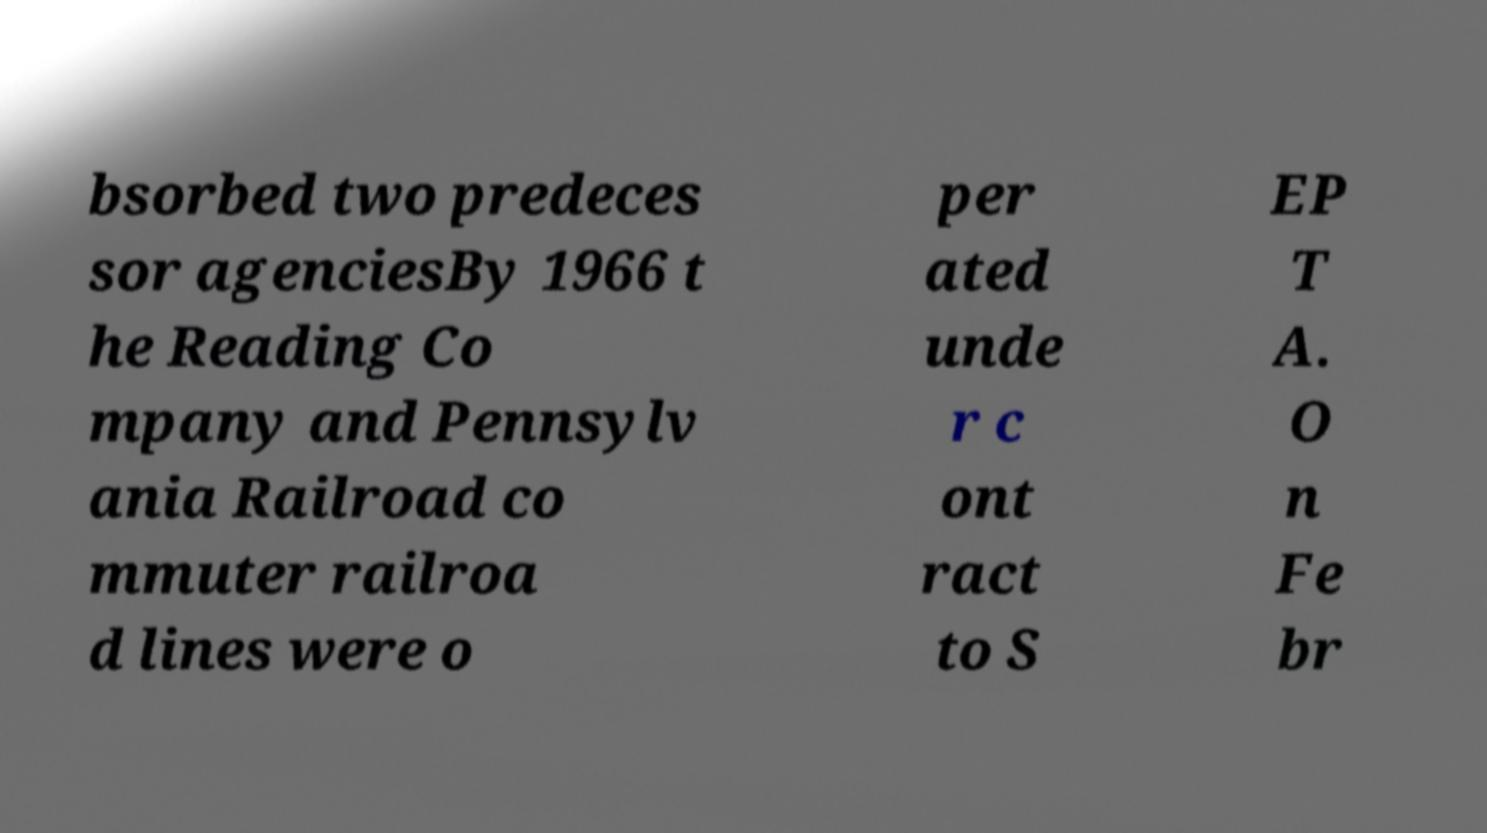I need the written content from this picture converted into text. Can you do that? bsorbed two predeces sor agenciesBy 1966 t he Reading Co mpany and Pennsylv ania Railroad co mmuter railroa d lines were o per ated unde r c ont ract to S EP T A. O n Fe br 